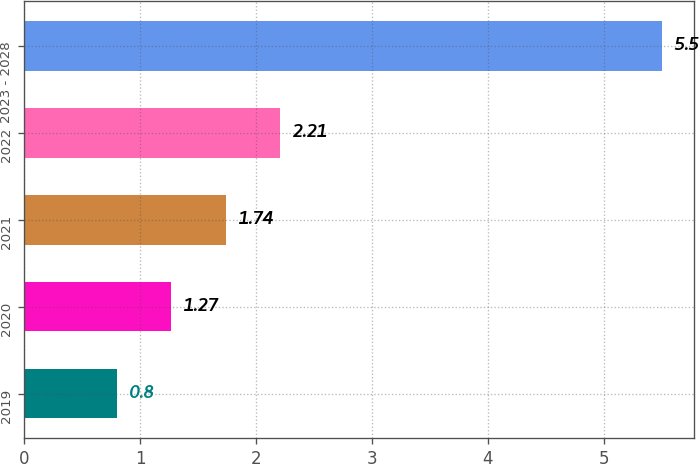Convert chart. <chart><loc_0><loc_0><loc_500><loc_500><bar_chart><fcel>2019<fcel>2020<fcel>2021<fcel>2022<fcel>2023 - 2028<nl><fcel>0.8<fcel>1.27<fcel>1.74<fcel>2.21<fcel>5.5<nl></chart> 